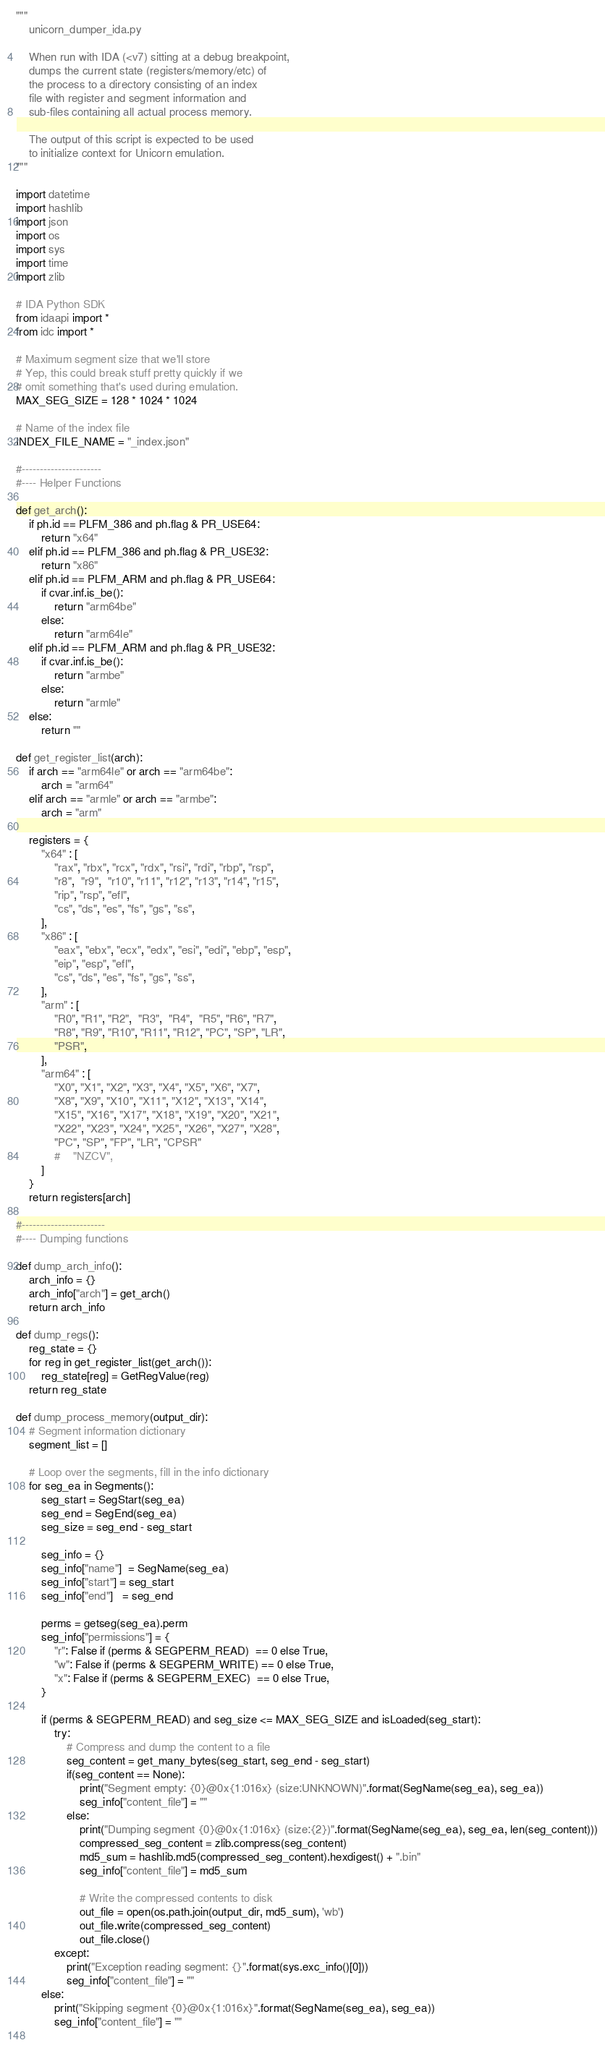Convert code to text. <code><loc_0><loc_0><loc_500><loc_500><_Python_>"""
    unicorn_dumper_ida.py
    
    When run with IDA (<v7) sitting at a debug breakpoint, 
    dumps the current state (registers/memory/etc) of
    the process to a directory consisting of an index 
    file with register and segment information and 
    sub-files containing all actual process memory.
    
    The output of this script is expected to be used 
    to initialize context for Unicorn emulation.
"""

import datetime
import hashlib
import json
import os
import sys
import time
import zlib

# IDA Python SDK
from idaapi import *
from idc import *

# Maximum segment size that we'll store
# Yep, this could break stuff pretty quickly if we
# omit something that's used during emulation.
MAX_SEG_SIZE = 128 * 1024 * 1024

# Name of the index file
INDEX_FILE_NAME = "_index.json"

#----------------------
#---- Helper Functions

def get_arch():
    if ph.id == PLFM_386 and ph.flag & PR_USE64:
        return "x64"
    elif ph.id == PLFM_386 and ph.flag & PR_USE32:
        return "x86"
    elif ph.id == PLFM_ARM and ph.flag & PR_USE64:
        if cvar.inf.is_be():
            return "arm64be"
        else:
            return "arm64le"
    elif ph.id == PLFM_ARM and ph.flag & PR_USE32:
        if cvar.inf.is_be():
            return "armbe"
        else:
            return "armle"
    else:
        return ""

def get_register_list(arch):
    if arch == "arm64le" or arch == "arm64be":
        arch = "arm64"
    elif arch == "armle" or arch == "armbe":
        arch = "arm"

    registers = {
        "x64" : [
            "rax", "rbx", "rcx", "rdx", "rsi", "rdi", "rbp", "rsp",
            "r8",  "r9",  "r10", "r11", "r12", "r13", "r14", "r15",
            "rip", "rsp", "efl",
            "cs", "ds", "es", "fs", "gs", "ss",
        ],
        "x86" : [
            "eax", "ebx", "ecx", "edx", "esi", "edi", "ebp", "esp",
            "eip", "esp", "efl", 
            "cs", "ds", "es", "fs", "gs", "ss",
        ],        
        "arm" : [
            "R0", "R1", "R2",  "R3",  "R4",  "R5", "R6", "R7",  
            "R8", "R9", "R10", "R11", "R12", "PC", "SP", "LR",  
            "PSR",
        ],
        "arm64" : [
            "X0", "X1", "X2", "X3", "X4", "X5", "X6", "X7",  
            "X8", "X9", "X10", "X11", "X12", "X13", "X14", 
            "X15", "X16", "X17", "X18", "X19", "X20", "X21", 
            "X22", "X23", "X24", "X25", "X26", "X27", "X28", 
            "PC", "SP", "FP", "LR", "CPSR"
            #    "NZCV",
        ]
    }
    return registers[arch]  

#-----------------------
#---- Dumping functions

def dump_arch_info():
    arch_info = {}
    arch_info["arch"] = get_arch()
    return arch_info

def dump_regs():
    reg_state = {}
    for reg in get_register_list(get_arch()):
        reg_state[reg] = GetRegValue(reg)
    return reg_state

def dump_process_memory(output_dir):
    # Segment information dictionary
    segment_list = []
    
    # Loop over the segments, fill in the info dictionary
    for seg_ea in Segments():
        seg_start = SegStart(seg_ea)
        seg_end = SegEnd(seg_ea)
        seg_size = seg_end - seg_start
		
        seg_info = {}
        seg_info["name"]  = SegName(seg_ea)
        seg_info["start"] = seg_start
        seg_info["end"]   = seg_end
        
        perms = getseg(seg_ea).perm
        seg_info["permissions"] = {
            "r": False if (perms & SEGPERM_READ)  == 0 else True,
            "w": False if (perms & SEGPERM_WRITE) == 0 else True,
            "x": False if (perms & SEGPERM_EXEC)  == 0 else True,
        }

        if (perms & SEGPERM_READ) and seg_size <= MAX_SEG_SIZE and isLoaded(seg_start):
            try:
                # Compress and dump the content to a file
                seg_content = get_many_bytes(seg_start, seg_end - seg_start)
                if(seg_content == None):
                    print("Segment empty: {0}@0x{1:016x} (size:UNKNOWN)".format(SegName(seg_ea), seg_ea))
                    seg_info["content_file"] = ""
                else:
                    print("Dumping segment {0}@0x{1:016x} (size:{2})".format(SegName(seg_ea), seg_ea, len(seg_content)))
                    compressed_seg_content = zlib.compress(seg_content)
                    md5_sum = hashlib.md5(compressed_seg_content).hexdigest() + ".bin"
                    seg_info["content_file"] = md5_sum
                    
                    # Write the compressed contents to disk
                    out_file = open(os.path.join(output_dir, md5_sum), 'wb')
                    out_file.write(compressed_seg_content)
                    out_file.close()
            except:
                print("Exception reading segment: {}".format(sys.exc_info()[0]))
                seg_info["content_file"] = ""
        else:
            print("Skipping segment {0}@0x{1:016x}".format(SegName(seg_ea), seg_ea))
            seg_info["content_file"] = ""
            </code> 